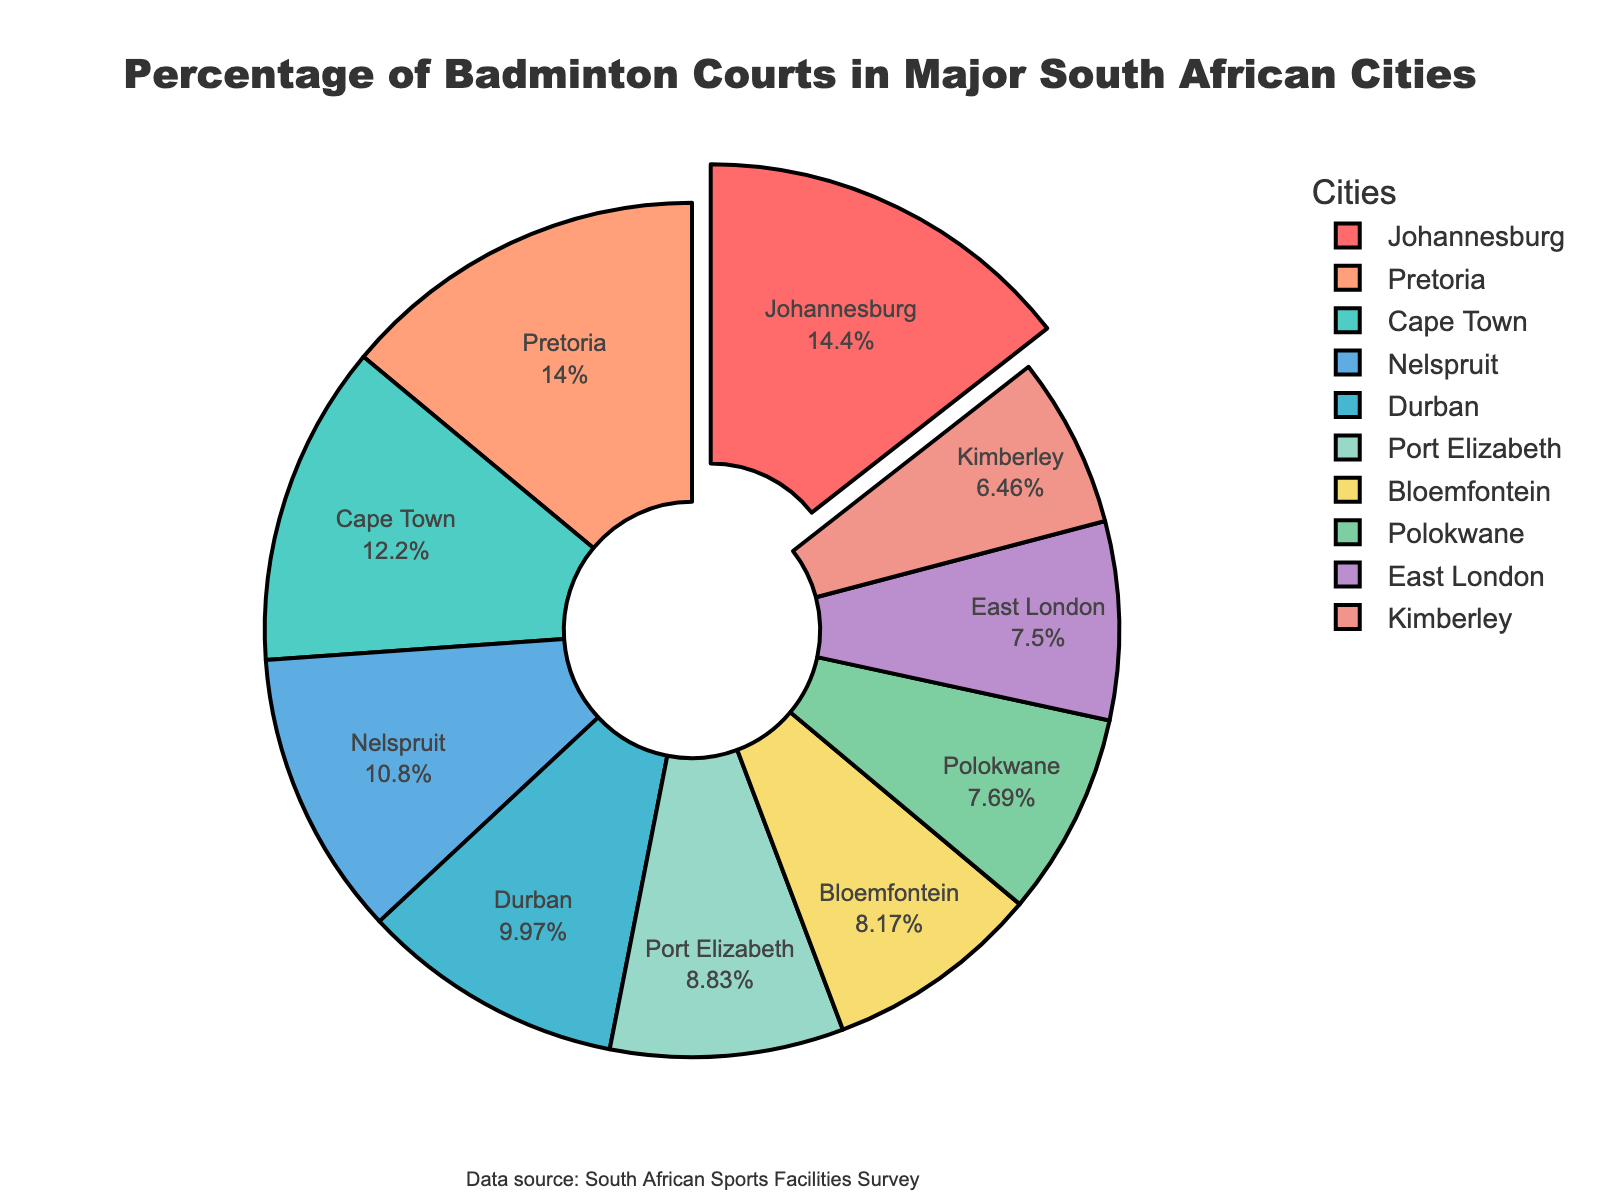What's the combined percentage of badminton courts in Johannesburg and Pretoria? Add the percentages for Johannesburg (15.2%) and Pretoria (14.7%). 15.2 + 14.7 = 29.9
Answer: 29.9 Which city has the highest percentage of badminton courts? The city with the highest percentage is pulled out from the chart. Johannesburg has the highest percentage at 15.2%.
Answer: Johannesburg How much higher is the percentage of badminton courts in Cape Town compared to East London? Subtract the percentage of East London (7.9%) from Cape Town (12.8%). 12.8 - 7.9 = 4.9
Answer: 4.9 What is the average percentage of badminton courts in the cities with percentages below 10%? The cities with percentages below 10% are Port Elizabeth (9.3%), Bloemfontein (8.6%), East London (7.9%), Kimberley (6.8%), and Polokwane (8.1%). Calculate the average: (9.3 + 8.6 + 7.9 + 6.8 + 8.1) / 5 = 8.14
Answer: 8.14 Which cities have a percentage lower than Durban but higher than Bloemfontein? Identify the cities with percentages between Durban (10.5%) and Bloemfontein (8.6%). They are: Port Elizabeth (9.3%), Nelspruit (11.4%), Polokwane (8.1%)
Answer: Port Elizabeth, Nelspruit, Polokwane If you combine the percentages for three cities with the lowest percentage of badminton courts, what is the total? The three cities with the lowest percentages are Kimberley (6.8%), Polokwane (8.1%), and East London (7.9%). Sum the percentages: 6.8 + 8.1 + 7.9 = 22.8
Answer: 22.8 Which city has the second highest percentage of badminton courts? The second highest percentage after Johannesburg is Pretoria with 14.7%.
Answer: Pretoria What's the difference in percentage between the city with the highest and the lowest percentage of badminton courts? The highest percentage is Johannesburg (15.2%) and the lowest is Kimberley (6.8%). Calculate the difference: 15.2 - 6.8 = 8.4
Answer: 8.4 What is the median percentage of badminton courts across all listed cities? Sort the percentages: [6.8, 7.9, 8.1, 8.6, 9.3, 10.5, 11.4, 12.8, 14.7, 15.2]. The median is the average of the 5th and 6th values: (9.3 + 10.5) / 2 = 9.9
Answer: 9.9 What is the total percentage of badminton courts in cities with percentages above 10%? Identify cities with percentages above 10%: Johannesburg (15.2%), Cape Town (12.8%), Durban (10.5%), Pretoria (14.7%), and Nelspruit (11.4%). Sum the percentages: 15.2 + 12.8 + 10.5 + 14.7 + 11.4 = 64.6
Answer: 64.6 